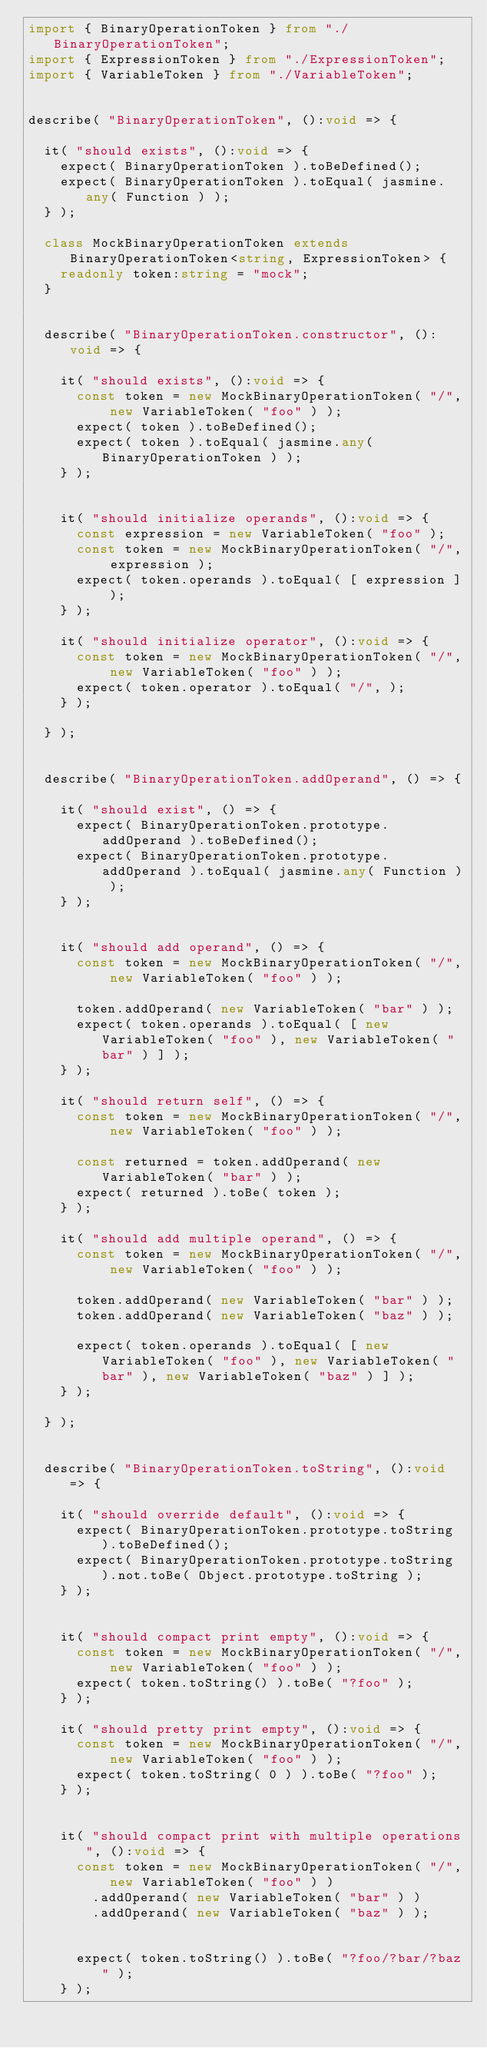Convert code to text. <code><loc_0><loc_0><loc_500><loc_500><_TypeScript_>import { BinaryOperationToken } from "./BinaryOperationToken";
import { ExpressionToken } from "./ExpressionToken";
import { VariableToken } from "./VariableToken";


describe( "BinaryOperationToken", ():void => {

	it( "should exists", ():void => {
		expect( BinaryOperationToken ).toBeDefined();
		expect( BinaryOperationToken ).toEqual( jasmine.any( Function ) );
	} );

	class MockBinaryOperationToken extends BinaryOperationToken<string, ExpressionToken> {
		readonly token:string = "mock";
	}


	describe( "BinaryOperationToken.constructor", ():void => {

		it( "should exists", ():void => {
			const token = new MockBinaryOperationToken( "/", new VariableToken( "foo" ) );
			expect( token ).toBeDefined();
			expect( token ).toEqual( jasmine.any( BinaryOperationToken ) );
		} );


		it( "should initialize operands", ():void => {
			const expression = new VariableToken( "foo" );
			const token = new MockBinaryOperationToken( "/", expression );
			expect( token.operands ).toEqual( [ expression ] );
		} );

		it( "should initialize operator", ():void => {
			const token = new MockBinaryOperationToken( "/", new VariableToken( "foo" ) );
			expect( token.operator ).toEqual( "/", );
		} );

	} );


	describe( "BinaryOperationToken.addOperand", () => {

		it( "should exist", () => {
			expect( BinaryOperationToken.prototype.addOperand ).toBeDefined();
			expect( BinaryOperationToken.prototype.addOperand ).toEqual( jasmine.any( Function ) );
		} );


		it( "should add operand", () => {
			const token = new MockBinaryOperationToken( "/", new VariableToken( "foo" ) );

			token.addOperand( new VariableToken( "bar" ) );
			expect( token.operands ).toEqual( [ new VariableToken( "foo" ), new VariableToken( "bar" ) ] );
		} );

		it( "should return self", () => {
			const token = new MockBinaryOperationToken( "/", new VariableToken( "foo" ) );

			const returned = token.addOperand( new VariableToken( "bar" ) );
			expect( returned ).toBe( token );
		} );

		it( "should add multiple operand", () => {
			const token = new MockBinaryOperationToken( "/", new VariableToken( "foo" ) );

			token.addOperand( new VariableToken( "bar" ) );
			token.addOperand( new VariableToken( "baz" ) );

			expect( token.operands ).toEqual( [ new VariableToken( "foo" ), new VariableToken( "bar" ), new VariableToken( "baz" ) ] );
		} );

	} );


	describe( "BinaryOperationToken.toString", ():void => {

		it( "should override default", ():void => {
			expect( BinaryOperationToken.prototype.toString ).toBeDefined();
			expect( BinaryOperationToken.prototype.toString ).not.toBe( Object.prototype.toString );
		} );


		it( "should compact print empty", ():void => {
			const token = new MockBinaryOperationToken( "/", new VariableToken( "foo" ) );
			expect( token.toString() ).toBe( "?foo" );
		} );

		it( "should pretty print empty", ():void => {
			const token = new MockBinaryOperationToken( "/", new VariableToken( "foo" ) );
			expect( token.toString( 0 ) ).toBe( "?foo" );
		} );


		it( "should compact print with multiple operations", ():void => {
			const token = new MockBinaryOperationToken( "/", new VariableToken( "foo" ) )
				.addOperand( new VariableToken( "bar" ) )
				.addOperand( new VariableToken( "baz" ) );


			expect( token.toString() ).toBe( "?foo/?bar/?baz" );
		} );
</code> 